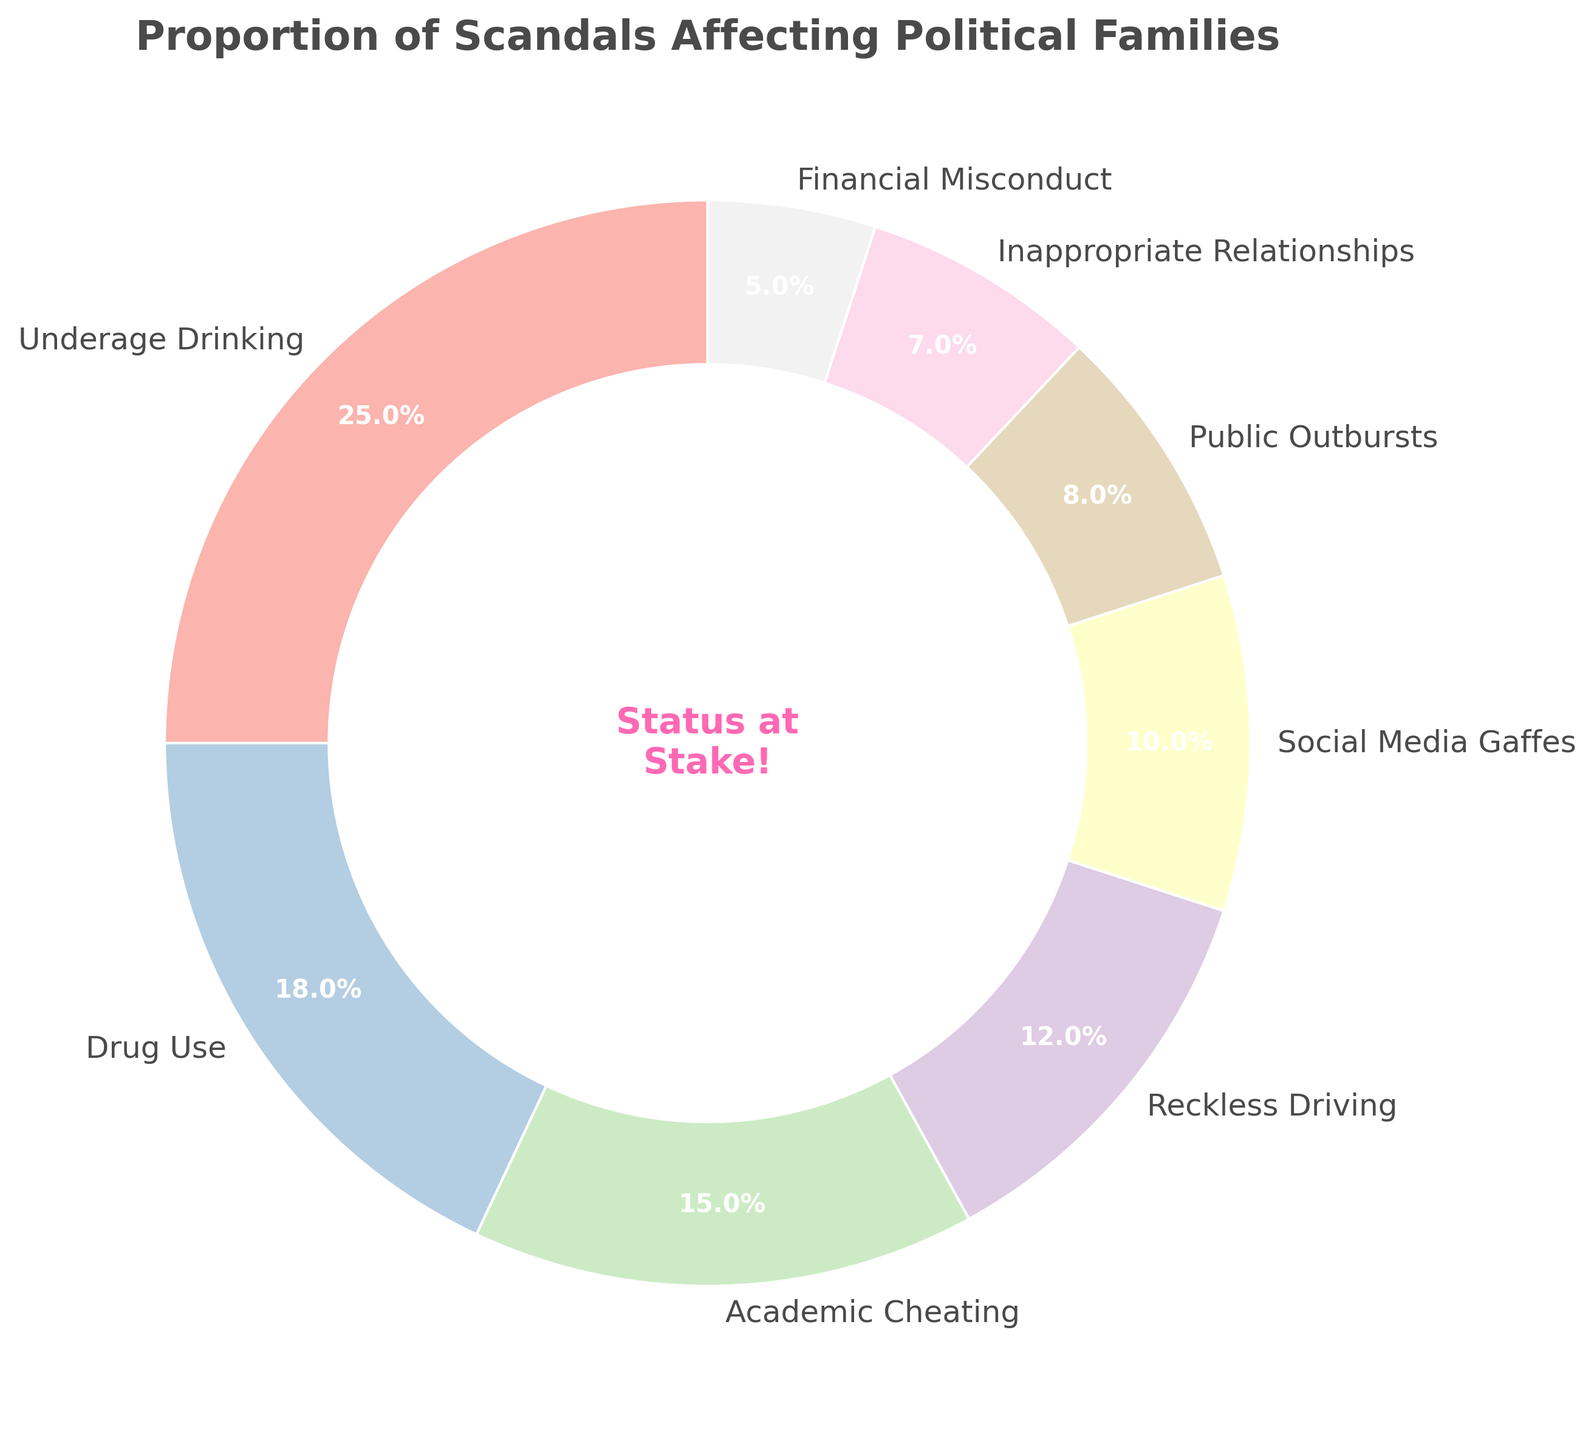What is the largest type of scandal affecting political families? The largest segment in the pie chart is labeled "Underage Drinking" with a percentage of 25%.
Answer: Underage Drinking Which type of scandal is least frequent? The smallest segment in the pie chart is labeled "Financial Misconduct" with a percentage of 5%.
Answer: Financial Misconduct What is the combined percentage of Drug Use and Academic Cheating scandals? Drug Use is 18% and Academic Cheating is 15%. Their combined percentage is 18 + 15 = 33%.
Answer: 33% How much larger is the percentage of Underage Drinking compared to Financial Misconduct? The percentage of Underage Drinking is 25% and Financial Misconduct is 5%. The difference is 25 - 5 = 20 percentage points.
Answer: 20 percentage points Arrange the types of scandals in descending order of their percentages. Listing the types of scandals from the largest percentage to the smallest: Underage Drinking (25%), Drug Use (18%), Academic Cheating (15%), Reckless Driving (12%), Social Media Gaffes (10%), Public Outbursts (8%), Inappropriate Relationships (7%), Financial Misconduct (5%).
Answer: Underage Drinking, Drug Use, Academic Cheating, Reckless Driving, Social Media Gaffes, Public Outbursts, Inappropriate Relationships, Financial Misconduct Are there more scandals related to specific behaviors (like Drinking and Drug Use) or non-behaviors (like Social Media Gaffes and Financial Misconduct)? Adding percentages of specific behaviors: Underage Drinking (25%) + Drug Use (18%) + Academic Cheating (15%) + Reckless Driving (12%) + Public Outbursts (8%) + Inappropriate Relationships (7%) = 85%. Adding percentages of non-behaviors: Social Media Gaffes (10%) + Financial Misconduct (5%) = 15%. Hence, there are more scandals related to specific behaviors.
Answer: Specific behaviors What is the combined percentage of the smallest three types of scandals? The smallest three types of scandals are Financial Misconduct (5%), Inappropriate Relationships (7%), and Public Outbursts (8%). Their combined percentage is 5 + 7 + 8 = 20%.
Answer: 20% Which scandal category lies in the middle of the spectrum when sorted by percentage? Sorting the types of scandals from smallest to largest and finding the middle value in a sorted list of 8 items: Financial Misconduct (5%), Inappropriate Relationships (7%), Public Outbursts (8%), Social Media Gaffes (10%), Reckless Driving (12%), Academic Cheating (15%), Drug Use (18%), and Underage Drinking (25%). The middle categories are Social Media Gaffes (10%) and Reckless Driving (12%).
Answer: Social Media Gaffes and Reckless Driving 